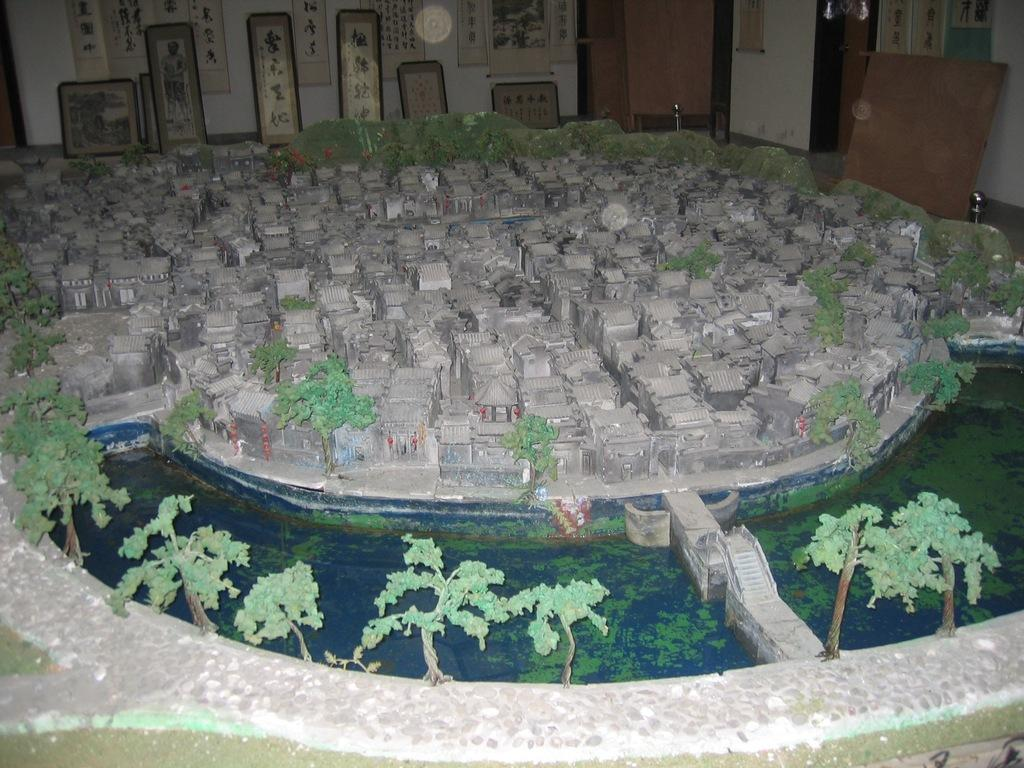What is the main subject of the image? The main subject of the image is a miniature. What types of structures are present in the miniature? There are houses and a wall in the miniature. What natural elements can be seen in the miniature? There are trees and water in the miniature. What architectural feature is present in the miniature? There is a bridge in the miniature. What additional objects are present in the miniature? There are boards, posters, and other objects in the miniature. Can you see a rake being used to clean the water in the miniature? There is no rake present in the image, and therefore no such activity can be observed. What type of treatment is being administered to the trees in the miniature? There is no treatment being administered to the trees in the miniature; they are simply depicted as part of the scene. 